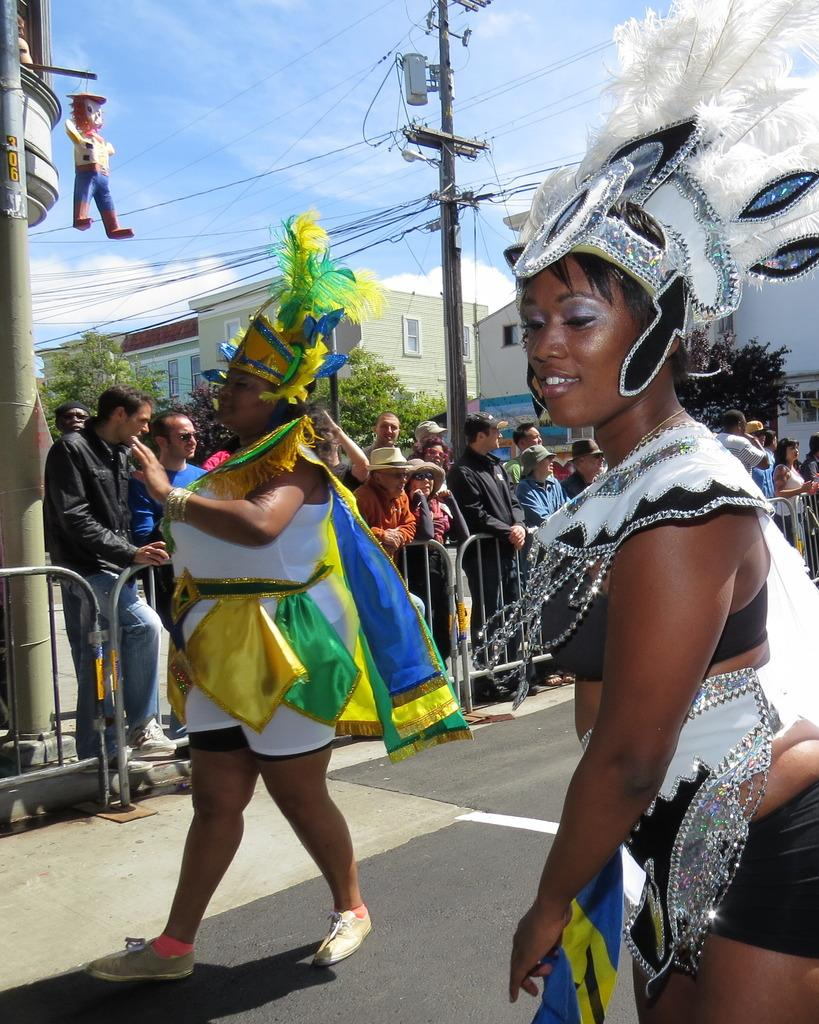How many people are in the image? There are two people in the image. What are the people wearing? The people are wearing different costumes. What can be seen in the background of the image? There is a fencing, trees, and buildings visible in the image. Are there any other people visible in the image? Yes, there are people visible in the image. What type of belief is being expressed by the bait in the image? There is no bait present in the image, and therefore no belief can be expressed by it. 